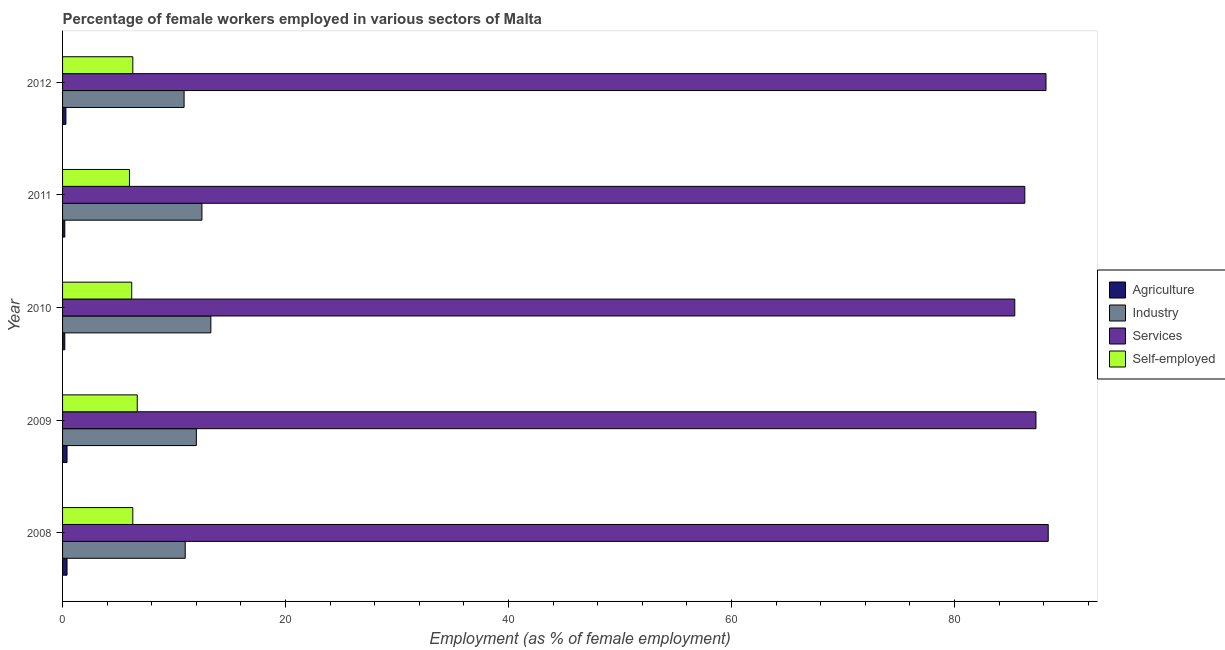How many different coloured bars are there?
Keep it short and to the point. 4. How many groups of bars are there?
Your response must be concise. 5. Are the number of bars per tick equal to the number of legend labels?
Give a very brief answer. Yes. How many bars are there on the 3rd tick from the bottom?
Give a very brief answer. 4. What is the label of the 2nd group of bars from the top?
Ensure brevity in your answer.  2011. What is the percentage of self employed female workers in 2008?
Ensure brevity in your answer.  6.3. Across all years, what is the maximum percentage of self employed female workers?
Offer a very short reply. 6.7. Across all years, what is the minimum percentage of female workers in services?
Your answer should be very brief. 85.4. In which year was the percentage of female workers in industry maximum?
Your answer should be compact. 2010. In which year was the percentage of female workers in agriculture minimum?
Provide a short and direct response. 2010. What is the total percentage of female workers in industry in the graph?
Offer a very short reply. 59.7. What is the difference between the percentage of female workers in industry in 2012 and the percentage of female workers in services in 2009?
Offer a very short reply. -76.4. What is the average percentage of female workers in services per year?
Offer a very short reply. 87.12. In the year 2012, what is the difference between the percentage of female workers in agriculture and percentage of female workers in services?
Ensure brevity in your answer.  -87.9. What is the ratio of the percentage of female workers in services in 2010 to that in 2011?
Provide a succinct answer. 0.99. What is the difference between the highest and the lowest percentage of female workers in industry?
Offer a terse response. 2.4. What does the 1st bar from the top in 2009 represents?
Offer a very short reply. Self-employed. What does the 3rd bar from the bottom in 2012 represents?
Provide a succinct answer. Services. Is it the case that in every year, the sum of the percentage of female workers in agriculture and percentage of female workers in industry is greater than the percentage of female workers in services?
Make the answer very short. No. How many bars are there?
Keep it short and to the point. 20. Are all the bars in the graph horizontal?
Provide a short and direct response. Yes. How many legend labels are there?
Provide a succinct answer. 4. How are the legend labels stacked?
Your answer should be compact. Vertical. What is the title of the graph?
Your answer should be compact. Percentage of female workers employed in various sectors of Malta. What is the label or title of the X-axis?
Your answer should be very brief. Employment (as % of female employment). What is the label or title of the Y-axis?
Offer a very short reply. Year. What is the Employment (as % of female employment) of Agriculture in 2008?
Your response must be concise. 0.4. What is the Employment (as % of female employment) in Services in 2008?
Offer a terse response. 88.4. What is the Employment (as % of female employment) in Self-employed in 2008?
Give a very brief answer. 6.3. What is the Employment (as % of female employment) of Agriculture in 2009?
Keep it short and to the point. 0.4. What is the Employment (as % of female employment) of Services in 2009?
Make the answer very short. 87.3. What is the Employment (as % of female employment) of Self-employed in 2009?
Make the answer very short. 6.7. What is the Employment (as % of female employment) in Agriculture in 2010?
Provide a short and direct response. 0.2. What is the Employment (as % of female employment) of Industry in 2010?
Offer a very short reply. 13.3. What is the Employment (as % of female employment) of Services in 2010?
Your answer should be compact. 85.4. What is the Employment (as % of female employment) of Self-employed in 2010?
Provide a short and direct response. 6.2. What is the Employment (as % of female employment) of Agriculture in 2011?
Provide a short and direct response. 0.2. What is the Employment (as % of female employment) of Services in 2011?
Give a very brief answer. 86.3. What is the Employment (as % of female employment) in Agriculture in 2012?
Your response must be concise. 0.3. What is the Employment (as % of female employment) of Industry in 2012?
Ensure brevity in your answer.  10.9. What is the Employment (as % of female employment) in Services in 2012?
Ensure brevity in your answer.  88.2. What is the Employment (as % of female employment) in Self-employed in 2012?
Ensure brevity in your answer.  6.3. Across all years, what is the maximum Employment (as % of female employment) in Agriculture?
Make the answer very short. 0.4. Across all years, what is the maximum Employment (as % of female employment) in Industry?
Offer a very short reply. 13.3. Across all years, what is the maximum Employment (as % of female employment) of Services?
Offer a terse response. 88.4. Across all years, what is the maximum Employment (as % of female employment) in Self-employed?
Offer a very short reply. 6.7. Across all years, what is the minimum Employment (as % of female employment) of Agriculture?
Offer a very short reply. 0.2. Across all years, what is the minimum Employment (as % of female employment) in Industry?
Make the answer very short. 10.9. Across all years, what is the minimum Employment (as % of female employment) in Services?
Provide a short and direct response. 85.4. Across all years, what is the minimum Employment (as % of female employment) of Self-employed?
Your response must be concise. 6. What is the total Employment (as % of female employment) of Agriculture in the graph?
Give a very brief answer. 1.5. What is the total Employment (as % of female employment) of Industry in the graph?
Offer a terse response. 59.7. What is the total Employment (as % of female employment) of Services in the graph?
Keep it short and to the point. 435.6. What is the total Employment (as % of female employment) in Self-employed in the graph?
Provide a succinct answer. 31.5. What is the difference between the Employment (as % of female employment) of Agriculture in 2008 and that in 2009?
Your answer should be very brief. 0. What is the difference between the Employment (as % of female employment) in Industry in 2008 and that in 2009?
Offer a terse response. -1. What is the difference between the Employment (as % of female employment) in Agriculture in 2008 and that in 2010?
Your answer should be very brief. 0.2. What is the difference between the Employment (as % of female employment) of Industry in 2008 and that in 2010?
Keep it short and to the point. -2.3. What is the difference between the Employment (as % of female employment) in Self-employed in 2008 and that in 2010?
Ensure brevity in your answer.  0.1. What is the difference between the Employment (as % of female employment) in Services in 2008 and that in 2011?
Your answer should be very brief. 2.1. What is the difference between the Employment (as % of female employment) in Industry in 2008 and that in 2012?
Provide a succinct answer. 0.1. What is the difference between the Employment (as % of female employment) in Services in 2008 and that in 2012?
Give a very brief answer. 0.2. What is the difference between the Employment (as % of female employment) of Agriculture in 2009 and that in 2010?
Give a very brief answer. 0.2. What is the difference between the Employment (as % of female employment) in Industry in 2009 and that in 2010?
Provide a short and direct response. -1.3. What is the difference between the Employment (as % of female employment) in Agriculture in 2009 and that in 2011?
Your answer should be compact. 0.2. What is the difference between the Employment (as % of female employment) in Industry in 2009 and that in 2011?
Keep it short and to the point. -0.5. What is the difference between the Employment (as % of female employment) in Self-employed in 2009 and that in 2011?
Your answer should be very brief. 0.7. What is the difference between the Employment (as % of female employment) of Services in 2009 and that in 2012?
Make the answer very short. -0.9. What is the difference between the Employment (as % of female employment) in Agriculture in 2010 and that in 2011?
Your response must be concise. 0. What is the difference between the Employment (as % of female employment) in Industry in 2010 and that in 2011?
Make the answer very short. 0.8. What is the difference between the Employment (as % of female employment) in Self-employed in 2010 and that in 2012?
Offer a terse response. -0.1. What is the difference between the Employment (as % of female employment) in Agriculture in 2011 and that in 2012?
Provide a short and direct response. -0.1. What is the difference between the Employment (as % of female employment) of Services in 2011 and that in 2012?
Your answer should be compact. -1.9. What is the difference between the Employment (as % of female employment) in Agriculture in 2008 and the Employment (as % of female employment) in Services in 2009?
Give a very brief answer. -86.9. What is the difference between the Employment (as % of female employment) in Agriculture in 2008 and the Employment (as % of female employment) in Self-employed in 2009?
Give a very brief answer. -6.3. What is the difference between the Employment (as % of female employment) in Industry in 2008 and the Employment (as % of female employment) in Services in 2009?
Keep it short and to the point. -76.3. What is the difference between the Employment (as % of female employment) in Services in 2008 and the Employment (as % of female employment) in Self-employed in 2009?
Your response must be concise. 81.7. What is the difference between the Employment (as % of female employment) of Agriculture in 2008 and the Employment (as % of female employment) of Services in 2010?
Ensure brevity in your answer.  -85. What is the difference between the Employment (as % of female employment) of Industry in 2008 and the Employment (as % of female employment) of Services in 2010?
Your answer should be compact. -74.4. What is the difference between the Employment (as % of female employment) in Services in 2008 and the Employment (as % of female employment) in Self-employed in 2010?
Ensure brevity in your answer.  82.2. What is the difference between the Employment (as % of female employment) of Agriculture in 2008 and the Employment (as % of female employment) of Services in 2011?
Keep it short and to the point. -85.9. What is the difference between the Employment (as % of female employment) in Agriculture in 2008 and the Employment (as % of female employment) in Self-employed in 2011?
Ensure brevity in your answer.  -5.6. What is the difference between the Employment (as % of female employment) in Industry in 2008 and the Employment (as % of female employment) in Services in 2011?
Offer a terse response. -75.3. What is the difference between the Employment (as % of female employment) in Industry in 2008 and the Employment (as % of female employment) in Self-employed in 2011?
Provide a short and direct response. 5. What is the difference between the Employment (as % of female employment) in Services in 2008 and the Employment (as % of female employment) in Self-employed in 2011?
Your response must be concise. 82.4. What is the difference between the Employment (as % of female employment) in Agriculture in 2008 and the Employment (as % of female employment) in Industry in 2012?
Provide a short and direct response. -10.5. What is the difference between the Employment (as % of female employment) of Agriculture in 2008 and the Employment (as % of female employment) of Services in 2012?
Your response must be concise. -87.8. What is the difference between the Employment (as % of female employment) of Agriculture in 2008 and the Employment (as % of female employment) of Self-employed in 2012?
Offer a very short reply. -5.9. What is the difference between the Employment (as % of female employment) of Industry in 2008 and the Employment (as % of female employment) of Services in 2012?
Give a very brief answer. -77.2. What is the difference between the Employment (as % of female employment) of Services in 2008 and the Employment (as % of female employment) of Self-employed in 2012?
Keep it short and to the point. 82.1. What is the difference between the Employment (as % of female employment) of Agriculture in 2009 and the Employment (as % of female employment) of Industry in 2010?
Offer a very short reply. -12.9. What is the difference between the Employment (as % of female employment) in Agriculture in 2009 and the Employment (as % of female employment) in Services in 2010?
Your response must be concise. -85. What is the difference between the Employment (as % of female employment) of Industry in 2009 and the Employment (as % of female employment) of Services in 2010?
Offer a very short reply. -73.4. What is the difference between the Employment (as % of female employment) of Services in 2009 and the Employment (as % of female employment) of Self-employed in 2010?
Make the answer very short. 81.1. What is the difference between the Employment (as % of female employment) of Agriculture in 2009 and the Employment (as % of female employment) of Industry in 2011?
Make the answer very short. -12.1. What is the difference between the Employment (as % of female employment) of Agriculture in 2009 and the Employment (as % of female employment) of Services in 2011?
Offer a terse response. -85.9. What is the difference between the Employment (as % of female employment) in Agriculture in 2009 and the Employment (as % of female employment) in Self-employed in 2011?
Ensure brevity in your answer.  -5.6. What is the difference between the Employment (as % of female employment) in Industry in 2009 and the Employment (as % of female employment) in Services in 2011?
Your answer should be compact. -74.3. What is the difference between the Employment (as % of female employment) of Industry in 2009 and the Employment (as % of female employment) of Self-employed in 2011?
Keep it short and to the point. 6. What is the difference between the Employment (as % of female employment) in Services in 2009 and the Employment (as % of female employment) in Self-employed in 2011?
Provide a succinct answer. 81.3. What is the difference between the Employment (as % of female employment) in Agriculture in 2009 and the Employment (as % of female employment) in Services in 2012?
Offer a very short reply. -87.8. What is the difference between the Employment (as % of female employment) of Industry in 2009 and the Employment (as % of female employment) of Services in 2012?
Your answer should be compact. -76.2. What is the difference between the Employment (as % of female employment) of Industry in 2009 and the Employment (as % of female employment) of Self-employed in 2012?
Your answer should be very brief. 5.7. What is the difference between the Employment (as % of female employment) in Agriculture in 2010 and the Employment (as % of female employment) in Industry in 2011?
Ensure brevity in your answer.  -12.3. What is the difference between the Employment (as % of female employment) in Agriculture in 2010 and the Employment (as % of female employment) in Services in 2011?
Offer a terse response. -86.1. What is the difference between the Employment (as % of female employment) of Agriculture in 2010 and the Employment (as % of female employment) of Self-employed in 2011?
Provide a short and direct response. -5.8. What is the difference between the Employment (as % of female employment) of Industry in 2010 and the Employment (as % of female employment) of Services in 2011?
Your answer should be compact. -73. What is the difference between the Employment (as % of female employment) of Industry in 2010 and the Employment (as % of female employment) of Self-employed in 2011?
Provide a succinct answer. 7.3. What is the difference between the Employment (as % of female employment) in Services in 2010 and the Employment (as % of female employment) in Self-employed in 2011?
Your answer should be compact. 79.4. What is the difference between the Employment (as % of female employment) in Agriculture in 2010 and the Employment (as % of female employment) in Services in 2012?
Your answer should be compact. -88. What is the difference between the Employment (as % of female employment) in Industry in 2010 and the Employment (as % of female employment) in Services in 2012?
Provide a short and direct response. -74.9. What is the difference between the Employment (as % of female employment) of Services in 2010 and the Employment (as % of female employment) of Self-employed in 2012?
Offer a terse response. 79.1. What is the difference between the Employment (as % of female employment) of Agriculture in 2011 and the Employment (as % of female employment) of Industry in 2012?
Provide a short and direct response. -10.7. What is the difference between the Employment (as % of female employment) of Agriculture in 2011 and the Employment (as % of female employment) of Services in 2012?
Provide a short and direct response. -88. What is the difference between the Employment (as % of female employment) of Agriculture in 2011 and the Employment (as % of female employment) of Self-employed in 2012?
Provide a succinct answer. -6.1. What is the difference between the Employment (as % of female employment) of Industry in 2011 and the Employment (as % of female employment) of Services in 2012?
Provide a short and direct response. -75.7. What is the average Employment (as % of female employment) of Industry per year?
Offer a terse response. 11.94. What is the average Employment (as % of female employment) of Services per year?
Give a very brief answer. 87.12. What is the average Employment (as % of female employment) in Self-employed per year?
Keep it short and to the point. 6.3. In the year 2008, what is the difference between the Employment (as % of female employment) in Agriculture and Employment (as % of female employment) in Industry?
Offer a terse response. -10.6. In the year 2008, what is the difference between the Employment (as % of female employment) in Agriculture and Employment (as % of female employment) in Services?
Your response must be concise. -88. In the year 2008, what is the difference between the Employment (as % of female employment) of Industry and Employment (as % of female employment) of Services?
Provide a succinct answer. -77.4. In the year 2008, what is the difference between the Employment (as % of female employment) in Industry and Employment (as % of female employment) in Self-employed?
Give a very brief answer. 4.7. In the year 2008, what is the difference between the Employment (as % of female employment) in Services and Employment (as % of female employment) in Self-employed?
Offer a terse response. 82.1. In the year 2009, what is the difference between the Employment (as % of female employment) of Agriculture and Employment (as % of female employment) of Services?
Offer a terse response. -86.9. In the year 2009, what is the difference between the Employment (as % of female employment) of Agriculture and Employment (as % of female employment) of Self-employed?
Provide a succinct answer. -6.3. In the year 2009, what is the difference between the Employment (as % of female employment) in Industry and Employment (as % of female employment) in Services?
Your answer should be very brief. -75.3. In the year 2009, what is the difference between the Employment (as % of female employment) of Services and Employment (as % of female employment) of Self-employed?
Provide a short and direct response. 80.6. In the year 2010, what is the difference between the Employment (as % of female employment) in Agriculture and Employment (as % of female employment) in Industry?
Give a very brief answer. -13.1. In the year 2010, what is the difference between the Employment (as % of female employment) of Agriculture and Employment (as % of female employment) of Services?
Your answer should be very brief. -85.2. In the year 2010, what is the difference between the Employment (as % of female employment) of Industry and Employment (as % of female employment) of Services?
Provide a succinct answer. -72.1. In the year 2010, what is the difference between the Employment (as % of female employment) of Services and Employment (as % of female employment) of Self-employed?
Provide a short and direct response. 79.2. In the year 2011, what is the difference between the Employment (as % of female employment) of Agriculture and Employment (as % of female employment) of Services?
Provide a short and direct response. -86.1. In the year 2011, what is the difference between the Employment (as % of female employment) of Agriculture and Employment (as % of female employment) of Self-employed?
Keep it short and to the point. -5.8. In the year 2011, what is the difference between the Employment (as % of female employment) in Industry and Employment (as % of female employment) in Services?
Ensure brevity in your answer.  -73.8. In the year 2011, what is the difference between the Employment (as % of female employment) of Industry and Employment (as % of female employment) of Self-employed?
Your answer should be compact. 6.5. In the year 2011, what is the difference between the Employment (as % of female employment) in Services and Employment (as % of female employment) in Self-employed?
Ensure brevity in your answer.  80.3. In the year 2012, what is the difference between the Employment (as % of female employment) of Agriculture and Employment (as % of female employment) of Services?
Your answer should be compact. -87.9. In the year 2012, what is the difference between the Employment (as % of female employment) in Industry and Employment (as % of female employment) in Services?
Provide a succinct answer. -77.3. In the year 2012, what is the difference between the Employment (as % of female employment) of Services and Employment (as % of female employment) of Self-employed?
Offer a terse response. 81.9. What is the ratio of the Employment (as % of female employment) in Industry in 2008 to that in 2009?
Your response must be concise. 0.92. What is the ratio of the Employment (as % of female employment) in Services in 2008 to that in 2009?
Provide a succinct answer. 1.01. What is the ratio of the Employment (as % of female employment) of Self-employed in 2008 to that in 2009?
Make the answer very short. 0.94. What is the ratio of the Employment (as % of female employment) of Agriculture in 2008 to that in 2010?
Your answer should be compact. 2. What is the ratio of the Employment (as % of female employment) of Industry in 2008 to that in 2010?
Offer a terse response. 0.83. What is the ratio of the Employment (as % of female employment) of Services in 2008 to that in 2010?
Your response must be concise. 1.04. What is the ratio of the Employment (as % of female employment) in Self-employed in 2008 to that in 2010?
Your response must be concise. 1.02. What is the ratio of the Employment (as % of female employment) of Industry in 2008 to that in 2011?
Offer a terse response. 0.88. What is the ratio of the Employment (as % of female employment) in Services in 2008 to that in 2011?
Ensure brevity in your answer.  1.02. What is the ratio of the Employment (as % of female employment) of Agriculture in 2008 to that in 2012?
Keep it short and to the point. 1.33. What is the ratio of the Employment (as % of female employment) in Industry in 2008 to that in 2012?
Keep it short and to the point. 1.01. What is the ratio of the Employment (as % of female employment) of Services in 2008 to that in 2012?
Ensure brevity in your answer.  1. What is the ratio of the Employment (as % of female employment) in Self-employed in 2008 to that in 2012?
Provide a short and direct response. 1. What is the ratio of the Employment (as % of female employment) in Agriculture in 2009 to that in 2010?
Provide a succinct answer. 2. What is the ratio of the Employment (as % of female employment) of Industry in 2009 to that in 2010?
Provide a succinct answer. 0.9. What is the ratio of the Employment (as % of female employment) in Services in 2009 to that in 2010?
Provide a short and direct response. 1.02. What is the ratio of the Employment (as % of female employment) in Self-employed in 2009 to that in 2010?
Provide a short and direct response. 1.08. What is the ratio of the Employment (as % of female employment) in Industry in 2009 to that in 2011?
Keep it short and to the point. 0.96. What is the ratio of the Employment (as % of female employment) of Services in 2009 to that in 2011?
Your response must be concise. 1.01. What is the ratio of the Employment (as % of female employment) in Self-employed in 2009 to that in 2011?
Give a very brief answer. 1.12. What is the ratio of the Employment (as % of female employment) in Agriculture in 2009 to that in 2012?
Your answer should be compact. 1.33. What is the ratio of the Employment (as % of female employment) of Industry in 2009 to that in 2012?
Your answer should be compact. 1.1. What is the ratio of the Employment (as % of female employment) of Services in 2009 to that in 2012?
Offer a terse response. 0.99. What is the ratio of the Employment (as % of female employment) in Self-employed in 2009 to that in 2012?
Give a very brief answer. 1.06. What is the ratio of the Employment (as % of female employment) in Industry in 2010 to that in 2011?
Ensure brevity in your answer.  1.06. What is the ratio of the Employment (as % of female employment) of Self-employed in 2010 to that in 2011?
Your response must be concise. 1.03. What is the ratio of the Employment (as % of female employment) in Agriculture in 2010 to that in 2012?
Your answer should be compact. 0.67. What is the ratio of the Employment (as % of female employment) of Industry in 2010 to that in 2012?
Your response must be concise. 1.22. What is the ratio of the Employment (as % of female employment) in Services in 2010 to that in 2012?
Provide a succinct answer. 0.97. What is the ratio of the Employment (as % of female employment) in Self-employed in 2010 to that in 2012?
Give a very brief answer. 0.98. What is the ratio of the Employment (as % of female employment) of Agriculture in 2011 to that in 2012?
Provide a short and direct response. 0.67. What is the ratio of the Employment (as % of female employment) of Industry in 2011 to that in 2012?
Your answer should be very brief. 1.15. What is the ratio of the Employment (as % of female employment) in Services in 2011 to that in 2012?
Provide a short and direct response. 0.98. What is the ratio of the Employment (as % of female employment) of Self-employed in 2011 to that in 2012?
Offer a very short reply. 0.95. What is the difference between the highest and the second highest Employment (as % of female employment) of Self-employed?
Your answer should be compact. 0.4. What is the difference between the highest and the lowest Employment (as % of female employment) in Agriculture?
Make the answer very short. 0.2. What is the difference between the highest and the lowest Employment (as % of female employment) in Industry?
Provide a short and direct response. 2.4. 